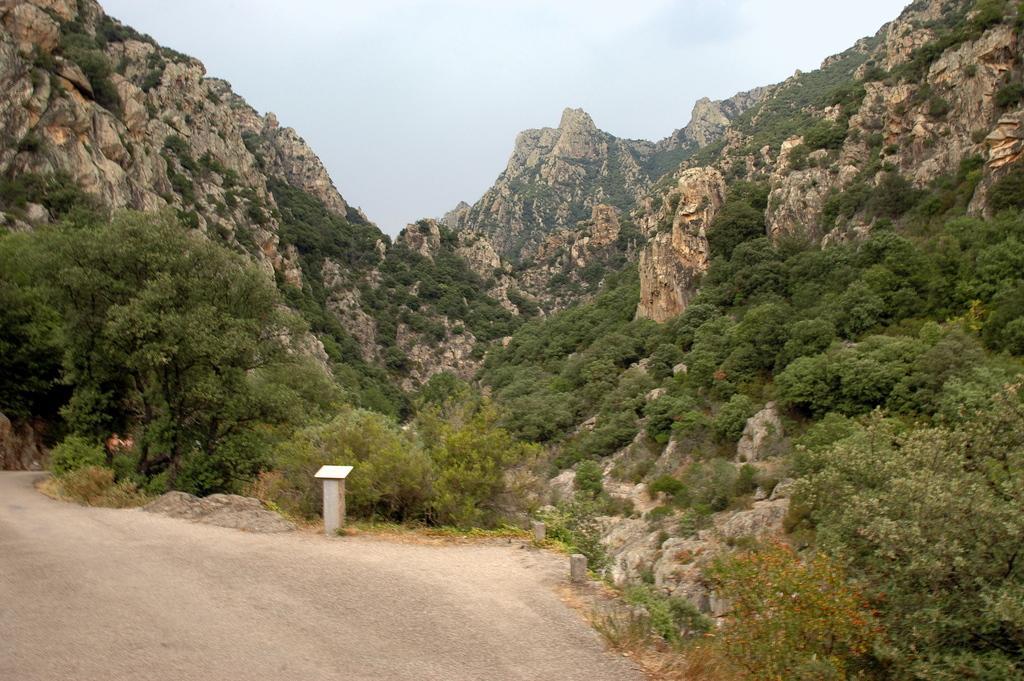Please provide a concise description of this image. In this image there is sky, there are mountains, there are trees, there are plants, there is road, there is an object on the ground. 